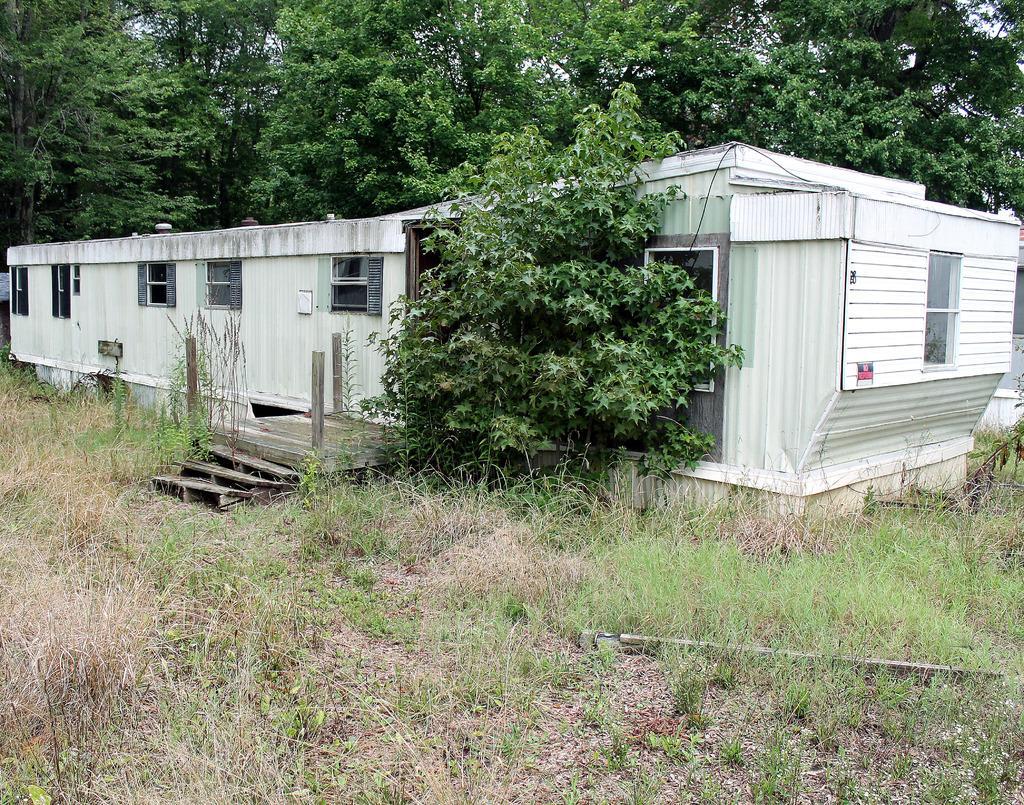Please provide a concise description of this image. In this image we can see a building, plants, grassy land and trees. Behind the trees, we can see the sky. 